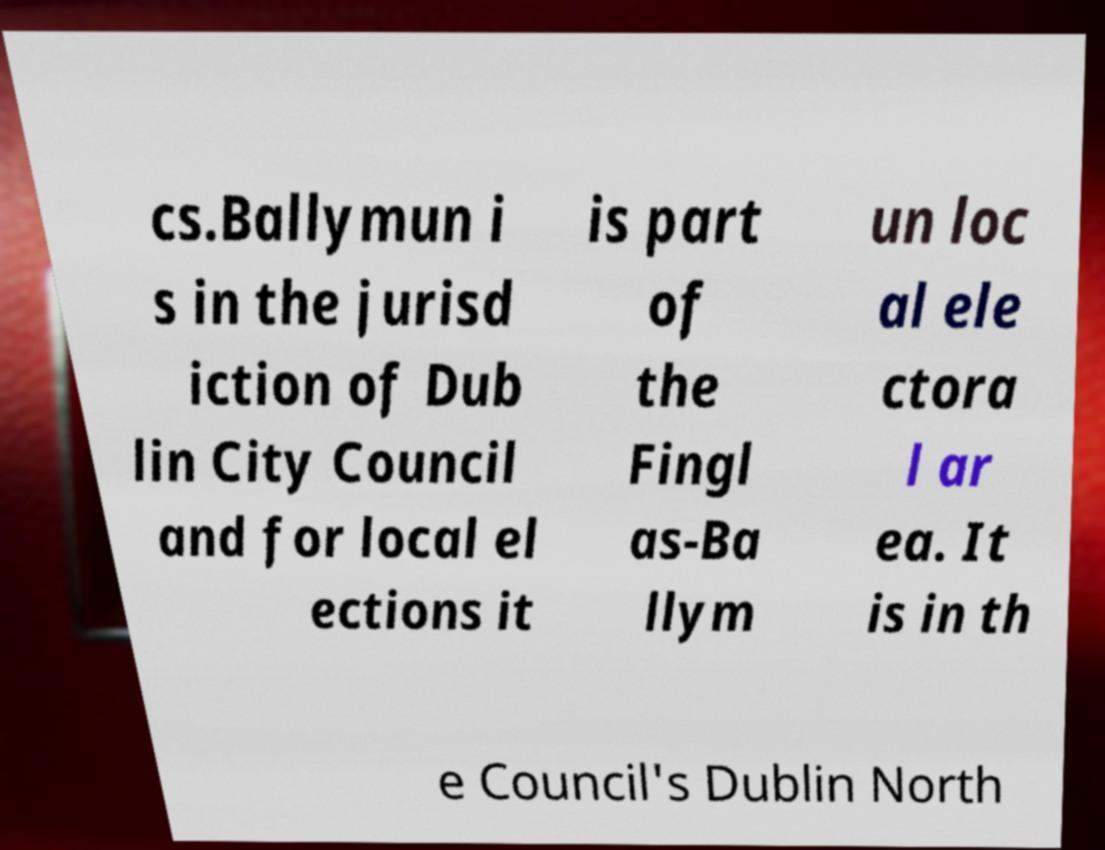Please read and relay the text visible in this image. What does it say? cs.Ballymun i s in the jurisd iction of Dub lin City Council and for local el ections it is part of the Fingl as-Ba llym un loc al ele ctora l ar ea. It is in th e Council's Dublin North 